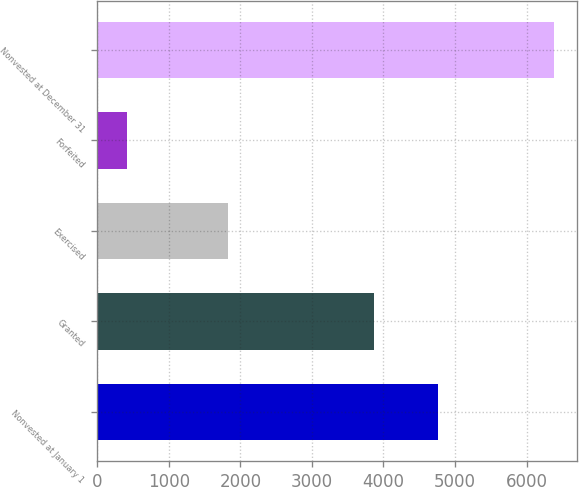<chart> <loc_0><loc_0><loc_500><loc_500><bar_chart><fcel>Nonvested at January 1<fcel>Granted<fcel>Exercised<fcel>Forfeited<fcel>Nonvested at December 31<nl><fcel>4764<fcel>3863<fcel>1826<fcel>422<fcel>6379<nl></chart> 